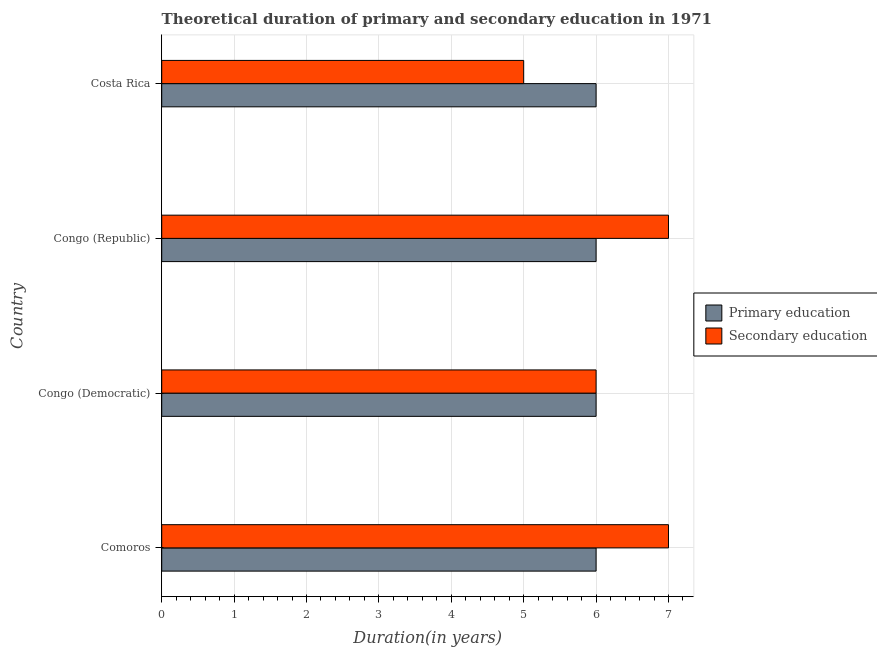How many different coloured bars are there?
Provide a short and direct response. 2. How many bars are there on the 2nd tick from the top?
Provide a succinct answer. 2. What is the label of the 3rd group of bars from the top?
Provide a succinct answer. Congo (Democratic). In how many cases, is the number of bars for a given country not equal to the number of legend labels?
Ensure brevity in your answer.  0. What is the duration of primary education in Congo (Democratic)?
Offer a terse response. 6. Across all countries, what is the maximum duration of primary education?
Keep it short and to the point. 6. Across all countries, what is the minimum duration of secondary education?
Your answer should be compact. 5. In which country was the duration of secondary education maximum?
Ensure brevity in your answer.  Comoros. What is the total duration of primary education in the graph?
Provide a short and direct response. 24. What is the difference between the duration of secondary education in Comoros and that in Costa Rica?
Provide a succinct answer. 2. What is the difference between the duration of primary education in Costa Rica and the duration of secondary education in Congo (Republic)?
Offer a very short reply. -1. What is the average duration of secondary education per country?
Offer a very short reply. 6.25. What is the difference between the duration of primary education and duration of secondary education in Congo (Republic)?
Your answer should be compact. -1. What is the ratio of the duration of secondary education in Comoros to that in Congo (Republic)?
Provide a succinct answer. 1. Is the duration of secondary education in Comoros less than that in Congo (Democratic)?
Your response must be concise. No. What is the difference between the highest and the lowest duration of secondary education?
Your answer should be very brief. 2. Is the sum of the duration of primary education in Congo (Democratic) and Congo (Republic) greater than the maximum duration of secondary education across all countries?
Provide a short and direct response. Yes. What does the 2nd bar from the top in Costa Rica represents?
Your answer should be very brief. Primary education. How many bars are there?
Make the answer very short. 8. How many countries are there in the graph?
Your answer should be compact. 4. What is the title of the graph?
Keep it short and to the point. Theoretical duration of primary and secondary education in 1971. What is the label or title of the X-axis?
Your answer should be very brief. Duration(in years). What is the label or title of the Y-axis?
Your answer should be very brief. Country. What is the Duration(in years) in Primary education in Comoros?
Offer a terse response. 6. What is the Duration(in years) of Secondary education in Comoros?
Provide a short and direct response. 7. What is the Duration(in years) in Primary education in Congo (Democratic)?
Your answer should be compact. 6. What is the Duration(in years) in Secondary education in Congo (Democratic)?
Offer a very short reply. 6. What is the Duration(in years) in Primary education in Congo (Republic)?
Provide a succinct answer. 6. What is the Duration(in years) of Secondary education in Costa Rica?
Provide a short and direct response. 5. Across all countries, what is the maximum Duration(in years) in Secondary education?
Your answer should be compact. 7. Across all countries, what is the minimum Duration(in years) in Primary education?
Your response must be concise. 6. What is the total Duration(in years) in Primary education in the graph?
Your response must be concise. 24. What is the difference between the Duration(in years) in Primary education in Comoros and that in Congo (Democratic)?
Keep it short and to the point. 0. What is the difference between the Duration(in years) of Primary education in Comoros and that in Congo (Republic)?
Your answer should be compact. 0. What is the difference between the Duration(in years) in Secondary education in Comoros and that in Congo (Republic)?
Your answer should be compact. 0. What is the difference between the Duration(in years) in Secondary education in Comoros and that in Costa Rica?
Your answer should be very brief. 2. What is the difference between the Duration(in years) of Secondary education in Congo (Democratic) and that in Congo (Republic)?
Make the answer very short. -1. What is the difference between the Duration(in years) of Primary education in Comoros and the Duration(in years) of Secondary education in Congo (Democratic)?
Make the answer very short. 0. What is the difference between the Duration(in years) of Primary education in Comoros and the Duration(in years) of Secondary education in Costa Rica?
Provide a short and direct response. 1. What is the average Duration(in years) in Secondary education per country?
Keep it short and to the point. 6.25. What is the difference between the Duration(in years) in Primary education and Duration(in years) in Secondary education in Comoros?
Provide a short and direct response. -1. What is the difference between the Duration(in years) of Primary education and Duration(in years) of Secondary education in Costa Rica?
Your answer should be compact. 1. What is the ratio of the Duration(in years) of Primary education in Comoros to that in Congo (Republic)?
Provide a short and direct response. 1. What is the ratio of the Duration(in years) in Primary education in Congo (Democratic) to that in Congo (Republic)?
Provide a succinct answer. 1. What is the ratio of the Duration(in years) in Secondary education in Congo (Democratic) to that in Congo (Republic)?
Give a very brief answer. 0.86. What is the difference between the highest and the second highest Duration(in years) in Secondary education?
Offer a very short reply. 0. What is the difference between the highest and the lowest Duration(in years) of Primary education?
Your answer should be very brief. 0. What is the difference between the highest and the lowest Duration(in years) in Secondary education?
Your response must be concise. 2. 